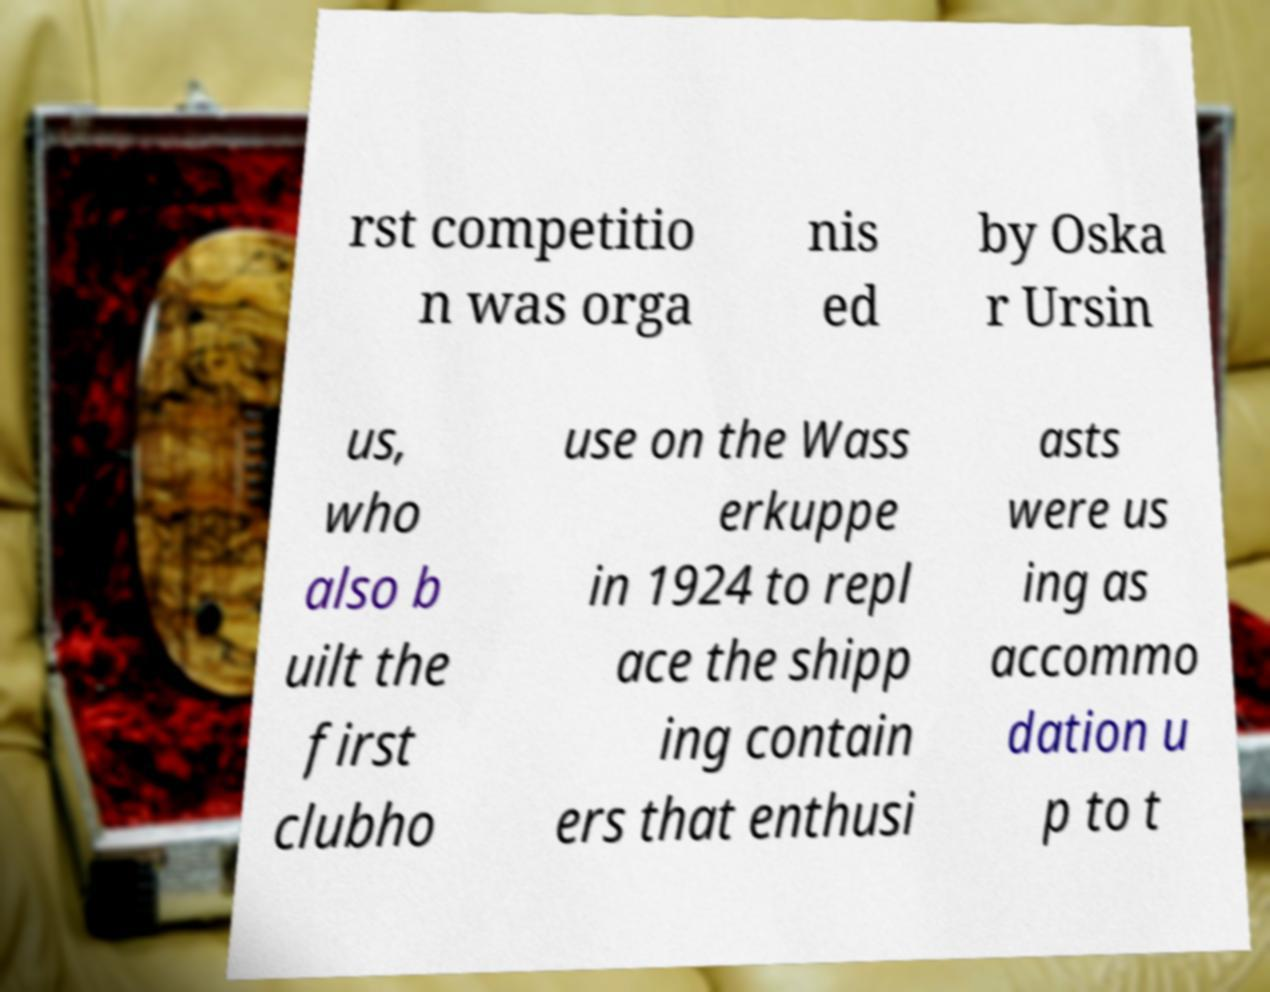Please identify and transcribe the text found in this image. rst competitio n was orga nis ed by Oska r Ursin us, who also b uilt the first clubho use on the Wass erkuppe in 1924 to repl ace the shipp ing contain ers that enthusi asts were us ing as accommo dation u p to t 